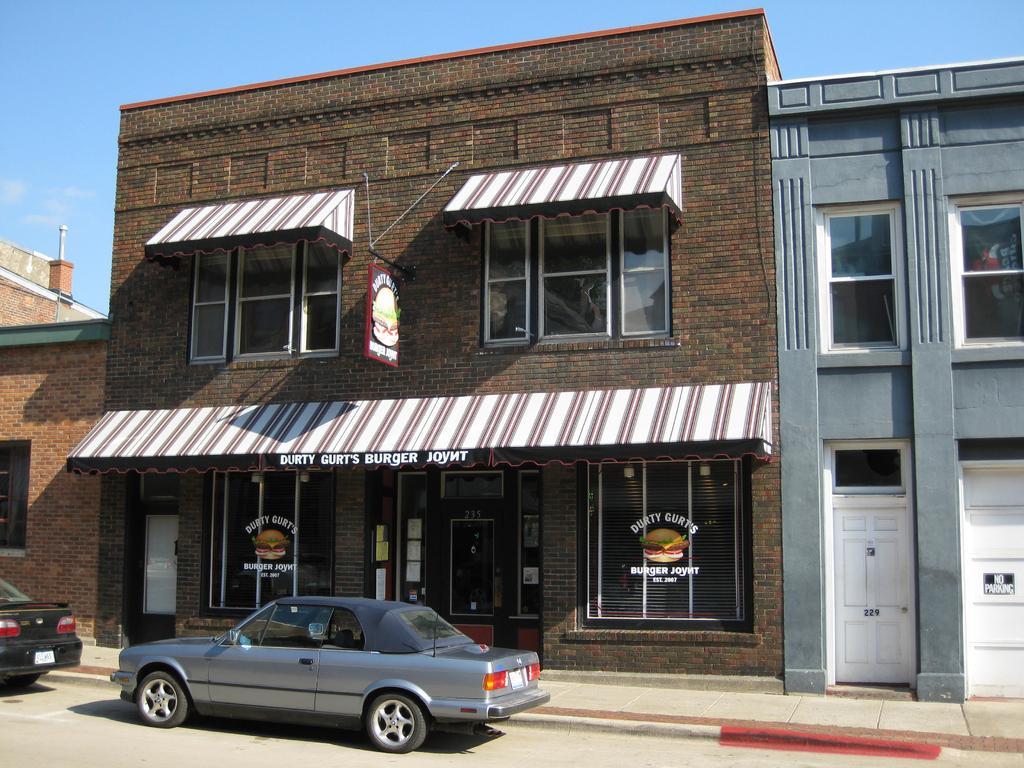Could you give a brief overview of what you see in this image? In this picture we can see the buildings. At the bottom there are two cars on the road. In the background we can see sky and clouds. On the wall we can see the board near the windows. 